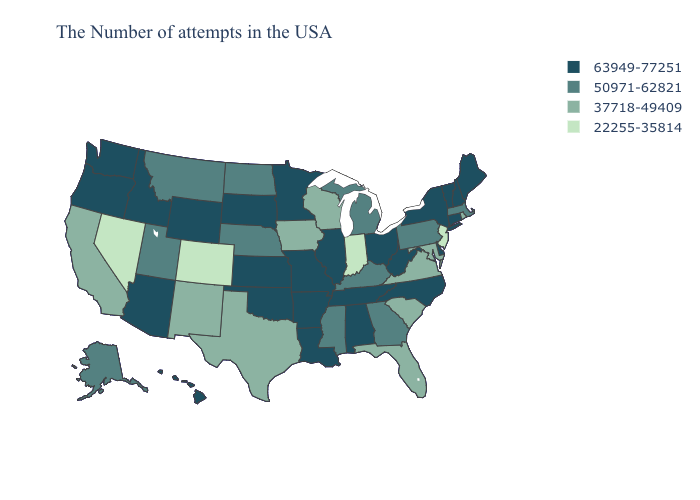Which states have the lowest value in the South?
Short answer required. Maryland, Virginia, South Carolina, Florida, Texas. What is the value of Washington?
Give a very brief answer. 63949-77251. Does California have a higher value than Michigan?
Be succinct. No. What is the value of Arizona?
Short answer required. 63949-77251. Does Tennessee have a lower value than Montana?
Short answer required. No. Among the states that border Washington , which have the highest value?
Short answer required. Idaho, Oregon. What is the value of Colorado?
Answer briefly. 22255-35814. Name the states that have a value in the range 37718-49409?
Keep it brief. Rhode Island, Maryland, Virginia, South Carolina, Florida, Wisconsin, Iowa, Texas, New Mexico, California. What is the value of New Hampshire?
Keep it brief. 63949-77251. What is the lowest value in the MidWest?
Write a very short answer. 22255-35814. Which states have the lowest value in the South?
Quick response, please. Maryland, Virginia, South Carolina, Florida, Texas. What is the value of Alaska?
Answer briefly. 50971-62821. Does the map have missing data?
Give a very brief answer. No. What is the lowest value in the USA?
Keep it brief. 22255-35814. Does New Mexico have a higher value than Nevada?
Be succinct. Yes. 